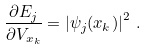<formula> <loc_0><loc_0><loc_500><loc_500>\frac { \partial E _ { j } } { \partial V _ { x _ { k } } } = \left | \psi _ { j } ( x _ { k } ) \right | ^ { 2 } \, .</formula> 